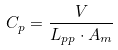Convert formula to latex. <formula><loc_0><loc_0><loc_500><loc_500>C _ { p } = \frac { V } { L _ { p p } \cdot A _ { m } }</formula> 